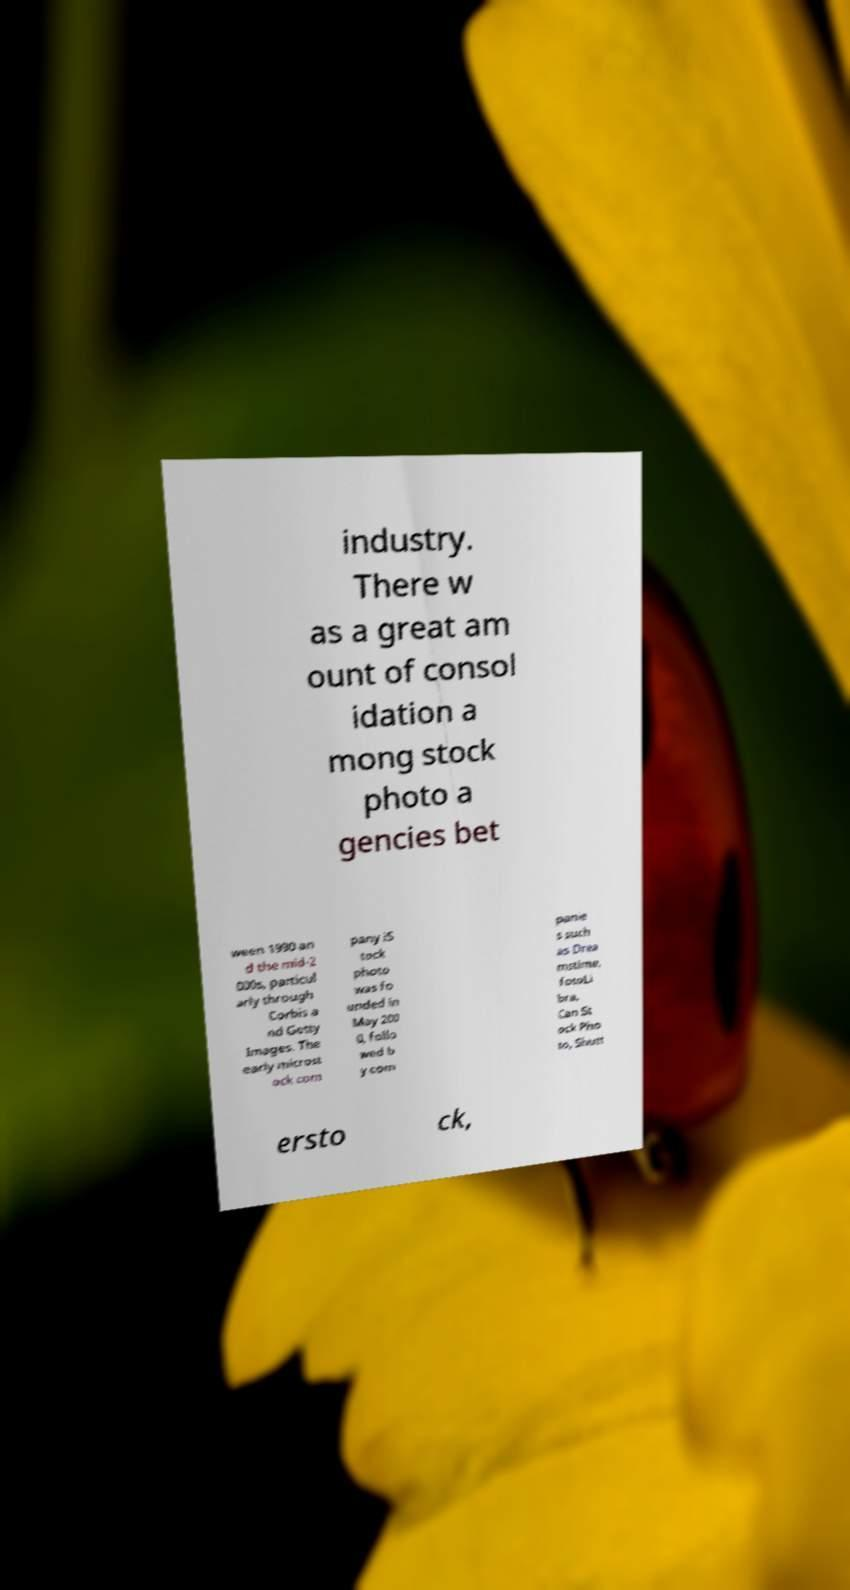Can you accurately transcribe the text from the provided image for me? industry. There w as a great am ount of consol idation a mong stock photo a gencies bet ween 1990 an d the mid-2 000s, particul arly through Corbis a nd Getty Images. The early microst ock com pany iS tock photo was fo unded in May 200 0, follo wed b y com panie s such as Drea mstime, fotoLi bra, Can St ock Pho to, Shutt ersto ck, 